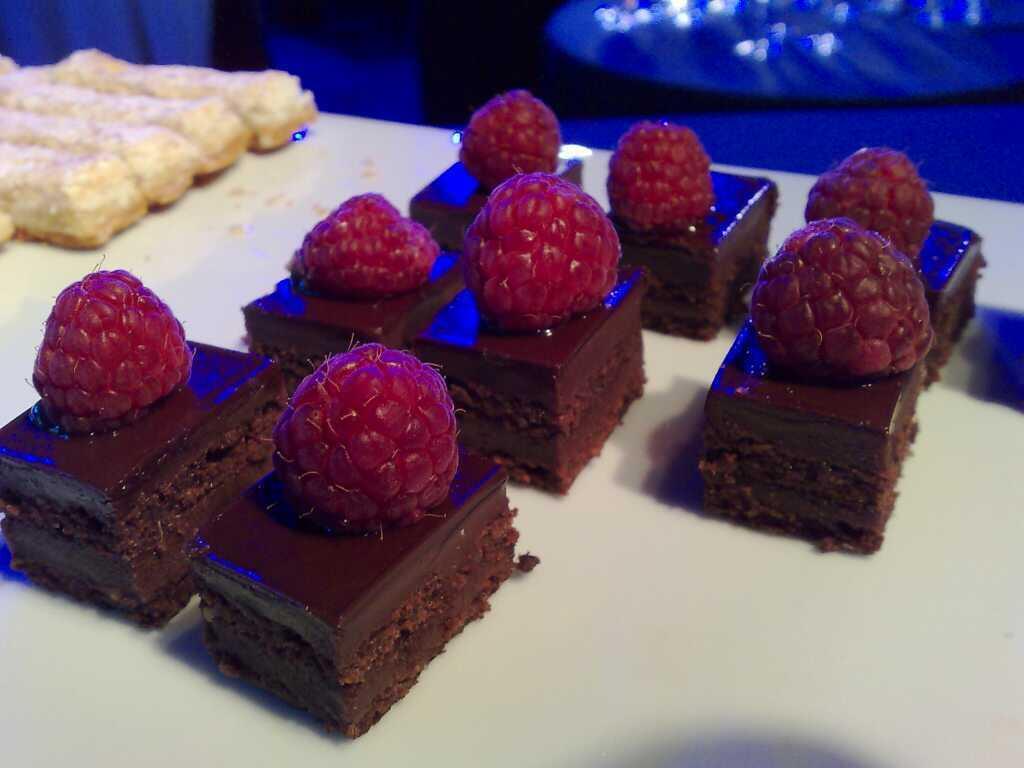Can you describe this image briefly? In this picture we can see a table, there are pieces of cake and some food placed on this table, we can see berries on these pieces. 